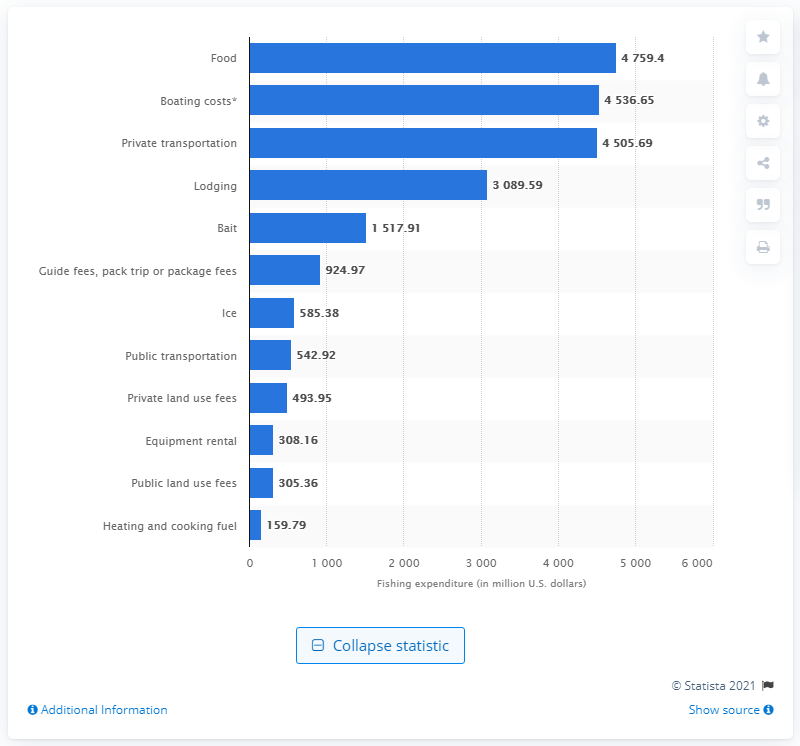Point out several critical features in this image. The amount of money spent on equipment rental for recreational fishing trips in the United States in 2016 was $308.16. 